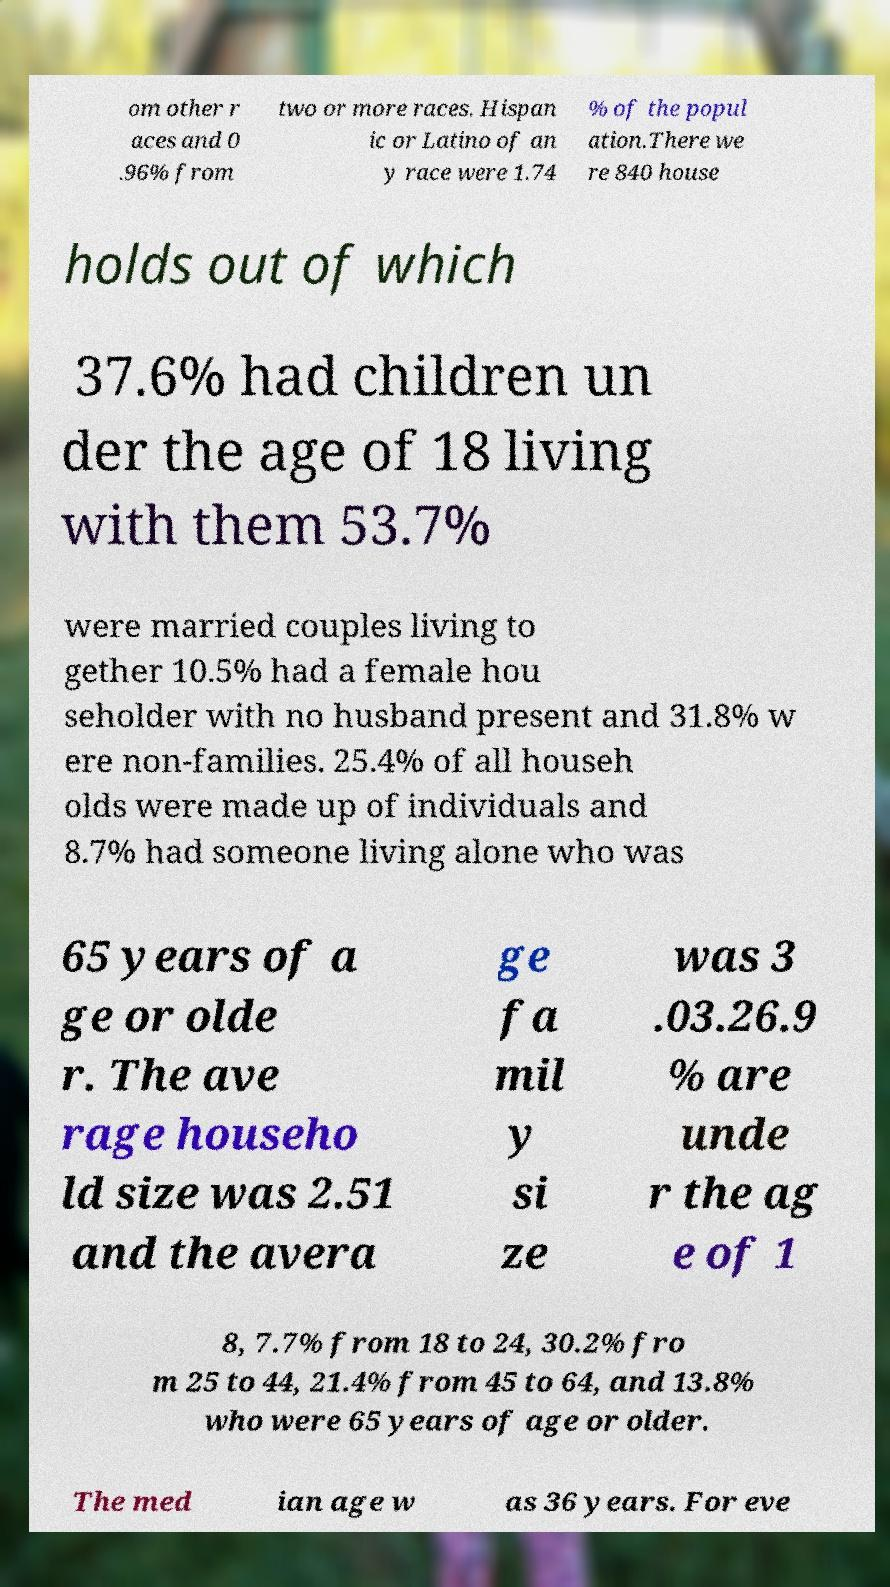Can you accurately transcribe the text from the provided image for me? om other r aces and 0 .96% from two or more races. Hispan ic or Latino of an y race were 1.74 % of the popul ation.There we re 840 house holds out of which 37.6% had children un der the age of 18 living with them 53.7% were married couples living to gether 10.5% had a female hou seholder with no husband present and 31.8% w ere non-families. 25.4% of all househ olds were made up of individuals and 8.7% had someone living alone who was 65 years of a ge or olde r. The ave rage househo ld size was 2.51 and the avera ge fa mil y si ze was 3 .03.26.9 % are unde r the ag e of 1 8, 7.7% from 18 to 24, 30.2% fro m 25 to 44, 21.4% from 45 to 64, and 13.8% who were 65 years of age or older. The med ian age w as 36 years. For eve 